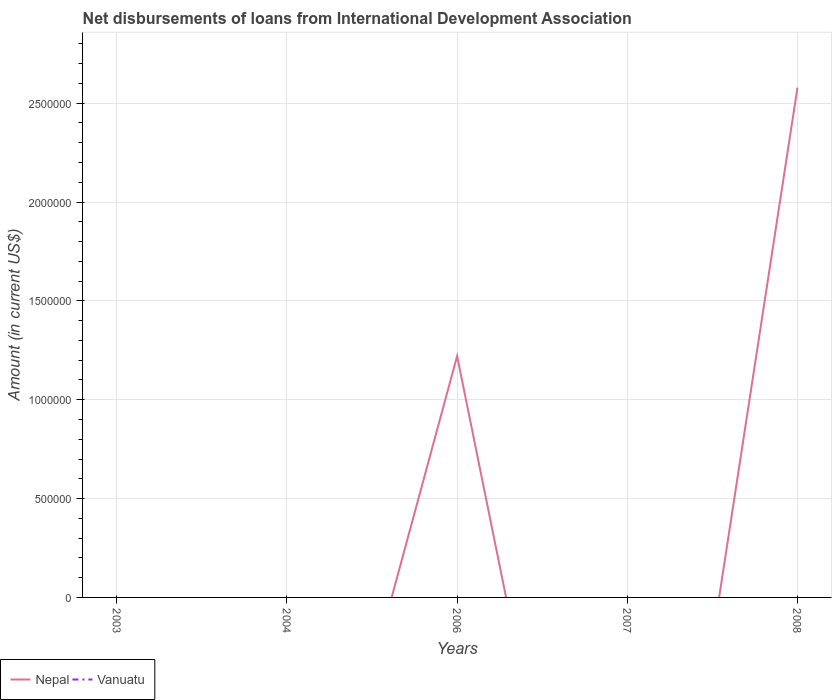How many different coloured lines are there?
Provide a succinct answer. 1. Does the line corresponding to Vanuatu intersect with the line corresponding to Nepal?
Give a very brief answer. Yes. Is the number of lines equal to the number of legend labels?
Ensure brevity in your answer.  No. Across all years, what is the maximum amount of loans disbursed in Vanuatu?
Your response must be concise. 0. What is the difference between the highest and the second highest amount of loans disbursed in Nepal?
Make the answer very short. 2.58e+06. Is the amount of loans disbursed in Nepal strictly greater than the amount of loans disbursed in Vanuatu over the years?
Make the answer very short. No. Does the graph contain grids?
Your answer should be compact. Yes. Where does the legend appear in the graph?
Make the answer very short. Bottom left. What is the title of the graph?
Your answer should be very brief. Net disbursements of loans from International Development Association. What is the label or title of the X-axis?
Provide a short and direct response. Years. What is the Amount (in current US$) of Nepal in 2003?
Make the answer very short. 0. What is the Amount (in current US$) of Vanuatu in 2003?
Give a very brief answer. 0. What is the Amount (in current US$) in Nepal in 2004?
Make the answer very short. 0. What is the Amount (in current US$) in Nepal in 2006?
Provide a succinct answer. 1.22e+06. What is the Amount (in current US$) in Vanuatu in 2007?
Offer a very short reply. 0. What is the Amount (in current US$) in Nepal in 2008?
Give a very brief answer. 2.58e+06. Across all years, what is the maximum Amount (in current US$) of Nepal?
Ensure brevity in your answer.  2.58e+06. Across all years, what is the minimum Amount (in current US$) in Nepal?
Ensure brevity in your answer.  0. What is the total Amount (in current US$) in Nepal in the graph?
Your answer should be very brief. 3.80e+06. What is the total Amount (in current US$) in Vanuatu in the graph?
Keep it short and to the point. 0. What is the difference between the Amount (in current US$) of Nepal in 2006 and that in 2008?
Your answer should be compact. -1.36e+06. What is the average Amount (in current US$) in Nepal per year?
Provide a succinct answer. 7.60e+05. What is the average Amount (in current US$) of Vanuatu per year?
Give a very brief answer. 0. What is the ratio of the Amount (in current US$) in Nepal in 2006 to that in 2008?
Make the answer very short. 0.47. What is the difference between the highest and the lowest Amount (in current US$) of Nepal?
Offer a very short reply. 2.58e+06. 